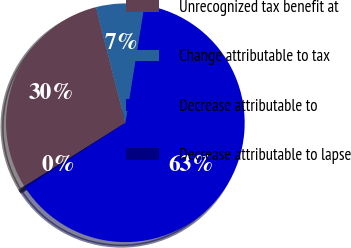<chart> <loc_0><loc_0><loc_500><loc_500><pie_chart><fcel>Unrecognized tax benefit at<fcel>Change attributable to tax<fcel>Decrease attributable to<fcel>Decrease attributable to lapse<nl><fcel>29.95%<fcel>6.53%<fcel>63.29%<fcel>0.23%<nl></chart> 